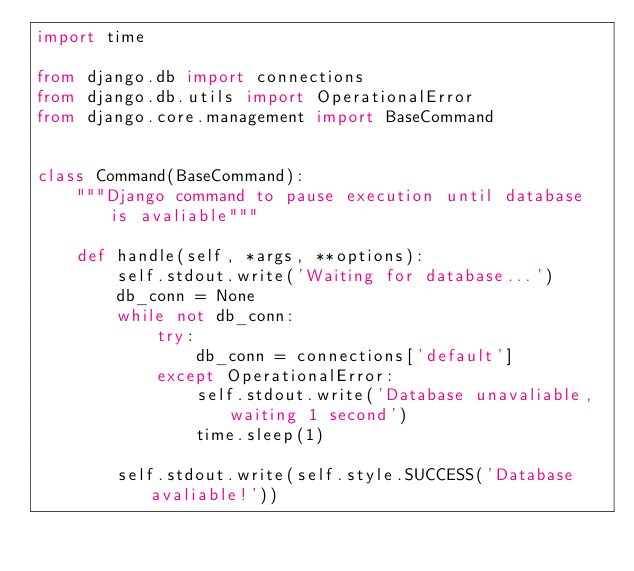<code> <loc_0><loc_0><loc_500><loc_500><_Python_>import time

from django.db import connections
from django.db.utils import OperationalError
from django.core.management import BaseCommand


class Command(BaseCommand):
    """Django command to pause execution until database is avaliable"""

    def handle(self, *args, **options):
        self.stdout.write('Waiting for database...')
        db_conn = None
        while not db_conn:
            try:
                db_conn = connections['default']
            except OperationalError:
                self.stdout.write('Database unavaliable, waiting 1 second')
                time.sleep(1)

        self.stdout.write(self.style.SUCCESS('Database avaliable!'))
</code> 